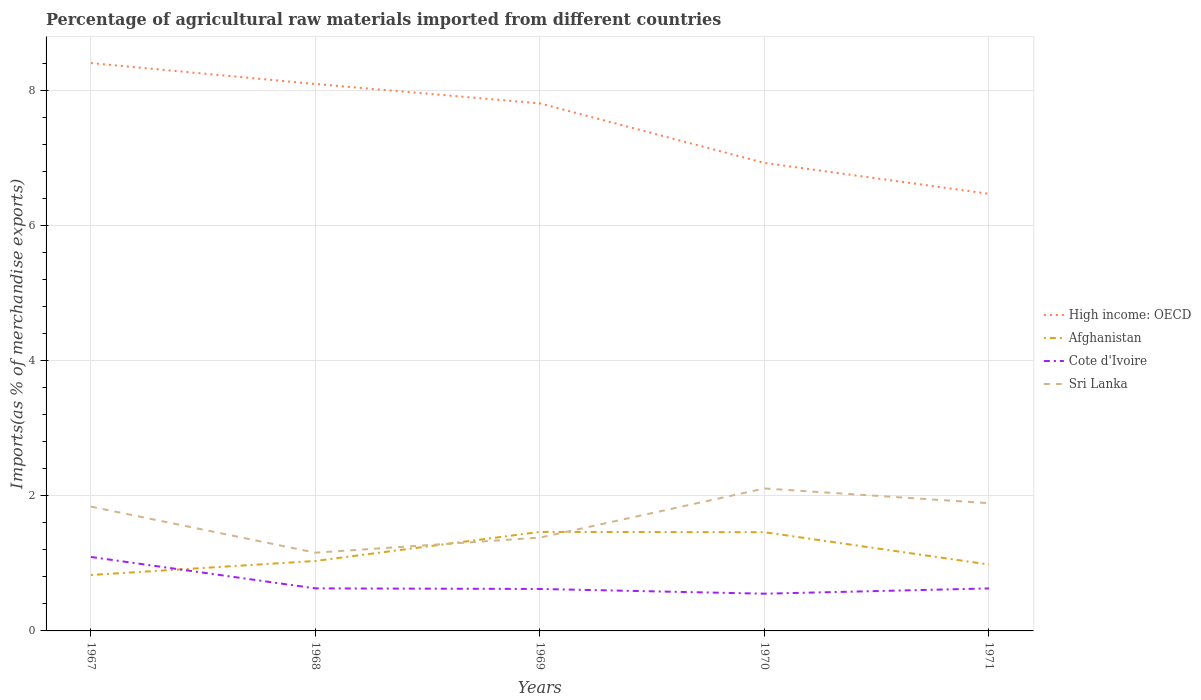How many different coloured lines are there?
Give a very brief answer. 4. Is the number of lines equal to the number of legend labels?
Give a very brief answer. Yes. Across all years, what is the maximum percentage of imports to different countries in Sri Lanka?
Your response must be concise. 1.16. What is the total percentage of imports to different countries in Sri Lanka in the graph?
Your response must be concise. -0.73. What is the difference between the highest and the second highest percentage of imports to different countries in Sri Lanka?
Offer a terse response. 0.95. How many lines are there?
Your answer should be compact. 4. What is the difference between two consecutive major ticks on the Y-axis?
Offer a terse response. 2. Are the values on the major ticks of Y-axis written in scientific E-notation?
Provide a succinct answer. No. Where does the legend appear in the graph?
Give a very brief answer. Center right. How many legend labels are there?
Offer a very short reply. 4. What is the title of the graph?
Offer a very short reply. Percentage of agricultural raw materials imported from different countries. Does "India" appear as one of the legend labels in the graph?
Offer a terse response. No. What is the label or title of the Y-axis?
Provide a succinct answer. Imports(as % of merchandise exports). What is the Imports(as % of merchandise exports) of High income: OECD in 1967?
Ensure brevity in your answer.  8.4. What is the Imports(as % of merchandise exports) of Afghanistan in 1967?
Provide a succinct answer. 0.83. What is the Imports(as % of merchandise exports) in Cote d'Ivoire in 1967?
Ensure brevity in your answer.  1.09. What is the Imports(as % of merchandise exports) in Sri Lanka in 1967?
Ensure brevity in your answer.  1.84. What is the Imports(as % of merchandise exports) of High income: OECD in 1968?
Provide a succinct answer. 8.09. What is the Imports(as % of merchandise exports) in Afghanistan in 1968?
Ensure brevity in your answer.  1.04. What is the Imports(as % of merchandise exports) of Cote d'Ivoire in 1968?
Give a very brief answer. 0.63. What is the Imports(as % of merchandise exports) in Sri Lanka in 1968?
Provide a short and direct response. 1.16. What is the Imports(as % of merchandise exports) of High income: OECD in 1969?
Provide a succinct answer. 7.8. What is the Imports(as % of merchandise exports) in Afghanistan in 1969?
Provide a succinct answer. 1.46. What is the Imports(as % of merchandise exports) of Cote d'Ivoire in 1969?
Make the answer very short. 0.62. What is the Imports(as % of merchandise exports) of Sri Lanka in 1969?
Give a very brief answer. 1.38. What is the Imports(as % of merchandise exports) in High income: OECD in 1970?
Your answer should be compact. 6.92. What is the Imports(as % of merchandise exports) in Afghanistan in 1970?
Give a very brief answer. 1.46. What is the Imports(as % of merchandise exports) of Cote d'Ivoire in 1970?
Make the answer very short. 0.55. What is the Imports(as % of merchandise exports) in Sri Lanka in 1970?
Make the answer very short. 2.11. What is the Imports(as % of merchandise exports) in High income: OECD in 1971?
Ensure brevity in your answer.  6.47. What is the Imports(as % of merchandise exports) of Afghanistan in 1971?
Your answer should be very brief. 0.98. What is the Imports(as % of merchandise exports) in Cote d'Ivoire in 1971?
Your response must be concise. 0.63. What is the Imports(as % of merchandise exports) in Sri Lanka in 1971?
Make the answer very short. 1.89. Across all years, what is the maximum Imports(as % of merchandise exports) of High income: OECD?
Ensure brevity in your answer.  8.4. Across all years, what is the maximum Imports(as % of merchandise exports) in Afghanistan?
Provide a succinct answer. 1.46. Across all years, what is the maximum Imports(as % of merchandise exports) of Cote d'Ivoire?
Offer a terse response. 1.09. Across all years, what is the maximum Imports(as % of merchandise exports) in Sri Lanka?
Give a very brief answer. 2.11. Across all years, what is the minimum Imports(as % of merchandise exports) of High income: OECD?
Offer a very short reply. 6.47. Across all years, what is the minimum Imports(as % of merchandise exports) in Afghanistan?
Provide a short and direct response. 0.83. Across all years, what is the minimum Imports(as % of merchandise exports) in Cote d'Ivoire?
Make the answer very short. 0.55. Across all years, what is the minimum Imports(as % of merchandise exports) in Sri Lanka?
Ensure brevity in your answer.  1.16. What is the total Imports(as % of merchandise exports) of High income: OECD in the graph?
Make the answer very short. 37.69. What is the total Imports(as % of merchandise exports) in Afghanistan in the graph?
Offer a terse response. 5.77. What is the total Imports(as % of merchandise exports) of Cote d'Ivoire in the graph?
Provide a short and direct response. 3.52. What is the total Imports(as % of merchandise exports) of Sri Lanka in the graph?
Give a very brief answer. 8.37. What is the difference between the Imports(as % of merchandise exports) in High income: OECD in 1967 and that in 1968?
Provide a succinct answer. 0.31. What is the difference between the Imports(as % of merchandise exports) of Afghanistan in 1967 and that in 1968?
Your answer should be very brief. -0.21. What is the difference between the Imports(as % of merchandise exports) in Cote d'Ivoire in 1967 and that in 1968?
Offer a terse response. 0.46. What is the difference between the Imports(as % of merchandise exports) in Sri Lanka in 1967 and that in 1968?
Ensure brevity in your answer.  0.68. What is the difference between the Imports(as % of merchandise exports) in High income: OECD in 1967 and that in 1969?
Offer a very short reply. 0.6. What is the difference between the Imports(as % of merchandise exports) of Afghanistan in 1967 and that in 1969?
Keep it short and to the point. -0.64. What is the difference between the Imports(as % of merchandise exports) in Cote d'Ivoire in 1967 and that in 1969?
Offer a very short reply. 0.47. What is the difference between the Imports(as % of merchandise exports) in Sri Lanka in 1967 and that in 1969?
Offer a terse response. 0.46. What is the difference between the Imports(as % of merchandise exports) of High income: OECD in 1967 and that in 1970?
Your response must be concise. 1.48. What is the difference between the Imports(as % of merchandise exports) of Afghanistan in 1967 and that in 1970?
Your answer should be very brief. -0.63. What is the difference between the Imports(as % of merchandise exports) of Cote d'Ivoire in 1967 and that in 1970?
Ensure brevity in your answer.  0.54. What is the difference between the Imports(as % of merchandise exports) of Sri Lanka in 1967 and that in 1970?
Provide a succinct answer. -0.27. What is the difference between the Imports(as % of merchandise exports) of High income: OECD in 1967 and that in 1971?
Keep it short and to the point. 1.93. What is the difference between the Imports(as % of merchandise exports) of Afghanistan in 1967 and that in 1971?
Provide a succinct answer. -0.15. What is the difference between the Imports(as % of merchandise exports) in Cote d'Ivoire in 1967 and that in 1971?
Make the answer very short. 0.47. What is the difference between the Imports(as % of merchandise exports) of Sri Lanka in 1967 and that in 1971?
Provide a short and direct response. -0.05. What is the difference between the Imports(as % of merchandise exports) in High income: OECD in 1968 and that in 1969?
Give a very brief answer. 0.29. What is the difference between the Imports(as % of merchandise exports) in Afghanistan in 1968 and that in 1969?
Ensure brevity in your answer.  -0.43. What is the difference between the Imports(as % of merchandise exports) in Cote d'Ivoire in 1968 and that in 1969?
Make the answer very short. 0.01. What is the difference between the Imports(as % of merchandise exports) in Sri Lanka in 1968 and that in 1969?
Ensure brevity in your answer.  -0.22. What is the difference between the Imports(as % of merchandise exports) in High income: OECD in 1968 and that in 1970?
Your answer should be very brief. 1.17. What is the difference between the Imports(as % of merchandise exports) of Afghanistan in 1968 and that in 1970?
Give a very brief answer. -0.43. What is the difference between the Imports(as % of merchandise exports) of Cote d'Ivoire in 1968 and that in 1970?
Provide a succinct answer. 0.08. What is the difference between the Imports(as % of merchandise exports) in Sri Lanka in 1968 and that in 1970?
Provide a short and direct response. -0.95. What is the difference between the Imports(as % of merchandise exports) in High income: OECD in 1968 and that in 1971?
Your answer should be compact. 1.62. What is the difference between the Imports(as % of merchandise exports) of Afghanistan in 1968 and that in 1971?
Offer a terse response. 0.05. What is the difference between the Imports(as % of merchandise exports) in Cote d'Ivoire in 1968 and that in 1971?
Keep it short and to the point. 0. What is the difference between the Imports(as % of merchandise exports) in Sri Lanka in 1968 and that in 1971?
Provide a short and direct response. -0.73. What is the difference between the Imports(as % of merchandise exports) of High income: OECD in 1969 and that in 1970?
Provide a short and direct response. 0.88. What is the difference between the Imports(as % of merchandise exports) in Afghanistan in 1969 and that in 1970?
Provide a short and direct response. 0. What is the difference between the Imports(as % of merchandise exports) in Cote d'Ivoire in 1969 and that in 1970?
Your response must be concise. 0.07. What is the difference between the Imports(as % of merchandise exports) of Sri Lanka in 1969 and that in 1970?
Your response must be concise. -0.73. What is the difference between the Imports(as % of merchandise exports) of High income: OECD in 1969 and that in 1971?
Your answer should be very brief. 1.34. What is the difference between the Imports(as % of merchandise exports) in Afghanistan in 1969 and that in 1971?
Provide a short and direct response. 0.48. What is the difference between the Imports(as % of merchandise exports) of Cote d'Ivoire in 1969 and that in 1971?
Provide a short and direct response. -0.01. What is the difference between the Imports(as % of merchandise exports) in Sri Lanka in 1969 and that in 1971?
Your response must be concise. -0.51. What is the difference between the Imports(as % of merchandise exports) of High income: OECD in 1970 and that in 1971?
Offer a terse response. 0.46. What is the difference between the Imports(as % of merchandise exports) in Afghanistan in 1970 and that in 1971?
Offer a very short reply. 0.48. What is the difference between the Imports(as % of merchandise exports) of Cote d'Ivoire in 1970 and that in 1971?
Keep it short and to the point. -0.08. What is the difference between the Imports(as % of merchandise exports) of Sri Lanka in 1970 and that in 1971?
Your response must be concise. 0.22. What is the difference between the Imports(as % of merchandise exports) in High income: OECD in 1967 and the Imports(as % of merchandise exports) in Afghanistan in 1968?
Ensure brevity in your answer.  7.37. What is the difference between the Imports(as % of merchandise exports) of High income: OECD in 1967 and the Imports(as % of merchandise exports) of Cote d'Ivoire in 1968?
Give a very brief answer. 7.77. What is the difference between the Imports(as % of merchandise exports) of High income: OECD in 1967 and the Imports(as % of merchandise exports) of Sri Lanka in 1968?
Offer a very short reply. 7.24. What is the difference between the Imports(as % of merchandise exports) in Afghanistan in 1967 and the Imports(as % of merchandise exports) in Cote d'Ivoire in 1968?
Offer a terse response. 0.2. What is the difference between the Imports(as % of merchandise exports) in Afghanistan in 1967 and the Imports(as % of merchandise exports) in Sri Lanka in 1968?
Your answer should be compact. -0.33. What is the difference between the Imports(as % of merchandise exports) in Cote d'Ivoire in 1967 and the Imports(as % of merchandise exports) in Sri Lanka in 1968?
Your response must be concise. -0.06. What is the difference between the Imports(as % of merchandise exports) of High income: OECD in 1967 and the Imports(as % of merchandise exports) of Afghanistan in 1969?
Give a very brief answer. 6.94. What is the difference between the Imports(as % of merchandise exports) of High income: OECD in 1967 and the Imports(as % of merchandise exports) of Cote d'Ivoire in 1969?
Keep it short and to the point. 7.78. What is the difference between the Imports(as % of merchandise exports) of High income: OECD in 1967 and the Imports(as % of merchandise exports) of Sri Lanka in 1969?
Make the answer very short. 7.02. What is the difference between the Imports(as % of merchandise exports) in Afghanistan in 1967 and the Imports(as % of merchandise exports) in Cote d'Ivoire in 1969?
Give a very brief answer. 0.21. What is the difference between the Imports(as % of merchandise exports) of Afghanistan in 1967 and the Imports(as % of merchandise exports) of Sri Lanka in 1969?
Offer a very short reply. -0.55. What is the difference between the Imports(as % of merchandise exports) of Cote d'Ivoire in 1967 and the Imports(as % of merchandise exports) of Sri Lanka in 1969?
Your response must be concise. -0.29. What is the difference between the Imports(as % of merchandise exports) of High income: OECD in 1967 and the Imports(as % of merchandise exports) of Afghanistan in 1970?
Keep it short and to the point. 6.94. What is the difference between the Imports(as % of merchandise exports) of High income: OECD in 1967 and the Imports(as % of merchandise exports) of Cote d'Ivoire in 1970?
Ensure brevity in your answer.  7.85. What is the difference between the Imports(as % of merchandise exports) in High income: OECD in 1967 and the Imports(as % of merchandise exports) in Sri Lanka in 1970?
Keep it short and to the point. 6.29. What is the difference between the Imports(as % of merchandise exports) of Afghanistan in 1967 and the Imports(as % of merchandise exports) of Cote d'Ivoire in 1970?
Offer a terse response. 0.28. What is the difference between the Imports(as % of merchandise exports) of Afghanistan in 1967 and the Imports(as % of merchandise exports) of Sri Lanka in 1970?
Provide a succinct answer. -1.28. What is the difference between the Imports(as % of merchandise exports) in Cote d'Ivoire in 1967 and the Imports(as % of merchandise exports) in Sri Lanka in 1970?
Provide a short and direct response. -1.01. What is the difference between the Imports(as % of merchandise exports) of High income: OECD in 1967 and the Imports(as % of merchandise exports) of Afghanistan in 1971?
Keep it short and to the point. 7.42. What is the difference between the Imports(as % of merchandise exports) of High income: OECD in 1967 and the Imports(as % of merchandise exports) of Cote d'Ivoire in 1971?
Offer a very short reply. 7.77. What is the difference between the Imports(as % of merchandise exports) of High income: OECD in 1967 and the Imports(as % of merchandise exports) of Sri Lanka in 1971?
Provide a succinct answer. 6.51. What is the difference between the Imports(as % of merchandise exports) of Afghanistan in 1967 and the Imports(as % of merchandise exports) of Cote d'Ivoire in 1971?
Your answer should be compact. 0.2. What is the difference between the Imports(as % of merchandise exports) in Afghanistan in 1967 and the Imports(as % of merchandise exports) in Sri Lanka in 1971?
Provide a short and direct response. -1.06. What is the difference between the Imports(as % of merchandise exports) in Cote d'Ivoire in 1967 and the Imports(as % of merchandise exports) in Sri Lanka in 1971?
Give a very brief answer. -0.8. What is the difference between the Imports(as % of merchandise exports) of High income: OECD in 1968 and the Imports(as % of merchandise exports) of Afghanistan in 1969?
Your response must be concise. 6.63. What is the difference between the Imports(as % of merchandise exports) in High income: OECD in 1968 and the Imports(as % of merchandise exports) in Cote d'Ivoire in 1969?
Offer a terse response. 7.47. What is the difference between the Imports(as % of merchandise exports) of High income: OECD in 1968 and the Imports(as % of merchandise exports) of Sri Lanka in 1969?
Your answer should be compact. 6.71. What is the difference between the Imports(as % of merchandise exports) in Afghanistan in 1968 and the Imports(as % of merchandise exports) in Cote d'Ivoire in 1969?
Your answer should be compact. 0.41. What is the difference between the Imports(as % of merchandise exports) of Afghanistan in 1968 and the Imports(as % of merchandise exports) of Sri Lanka in 1969?
Your answer should be compact. -0.35. What is the difference between the Imports(as % of merchandise exports) in Cote d'Ivoire in 1968 and the Imports(as % of merchandise exports) in Sri Lanka in 1969?
Provide a succinct answer. -0.75. What is the difference between the Imports(as % of merchandise exports) in High income: OECD in 1968 and the Imports(as % of merchandise exports) in Afghanistan in 1970?
Provide a succinct answer. 6.63. What is the difference between the Imports(as % of merchandise exports) in High income: OECD in 1968 and the Imports(as % of merchandise exports) in Cote d'Ivoire in 1970?
Give a very brief answer. 7.54. What is the difference between the Imports(as % of merchandise exports) of High income: OECD in 1968 and the Imports(as % of merchandise exports) of Sri Lanka in 1970?
Your answer should be very brief. 5.98. What is the difference between the Imports(as % of merchandise exports) in Afghanistan in 1968 and the Imports(as % of merchandise exports) in Cote d'Ivoire in 1970?
Offer a very short reply. 0.48. What is the difference between the Imports(as % of merchandise exports) of Afghanistan in 1968 and the Imports(as % of merchandise exports) of Sri Lanka in 1970?
Provide a short and direct response. -1.07. What is the difference between the Imports(as % of merchandise exports) in Cote d'Ivoire in 1968 and the Imports(as % of merchandise exports) in Sri Lanka in 1970?
Your answer should be very brief. -1.48. What is the difference between the Imports(as % of merchandise exports) in High income: OECD in 1968 and the Imports(as % of merchandise exports) in Afghanistan in 1971?
Make the answer very short. 7.11. What is the difference between the Imports(as % of merchandise exports) of High income: OECD in 1968 and the Imports(as % of merchandise exports) of Cote d'Ivoire in 1971?
Offer a terse response. 7.46. What is the difference between the Imports(as % of merchandise exports) in High income: OECD in 1968 and the Imports(as % of merchandise exports) in Sri Lanka in 1971?
Keep it short and to the point. 6.2. What is the difference between the Imports(as % of merchandise exports) in Afghanistan in 1968 and the Imports(as % of merchandise exports) in Cote d'Ivoire in 1971?
Your answer should be very brief. 0.41. What is the difference between the Imports(as % of merchandise exports) in Afghanistan in 1968 and the Imports(as % of merchandise exports) in Sri Lanka in 1971?
Your answer should be compact. -0.85. What is the difference between the Imports(as % of merchandise exports) in Cote d'Ivoire in 1968 and the Imports(as % of merchandise exports) in Sri Lanka in 1971?
Keep it short and to the point. -1.26. What is the difference between the Imports(as % of merchandise exports) in High income: OECD in 1969 and the Imports(as % of merchandise exports) in Afghanistan in 1970?
Your answer should be very brief. 6.34. What is the difference between the Imports(as % of merchandise exports) in High income: OECD in 1969 and the Imports(as % of merchandise exports) in Cote d'Ivoire in 1970?
Provide a succinct answer. 7.25. What is the difference between the Imports(as % of merchandise exports) in High income: OECD in 1969 and the Imports(as % of merchandise exports) in Sri Lanka in 1970?
Offer a very short reply. 5.7. What is the difference between the Imports(as % of merchandise exports) of Afghanistan in 1969 and the Imports(as % of merchandise exports) of Cote d'Ivoire in 1970?
Your answer should be compact. 0.91. What is the difference between the Imports(as % of merchandise exports) of Afghanistan in 1969 and the Imports(as % of merchandise exports) of Sri Lanka in 1970?
Your answer should be compact. -0.64. What is the difference between the Imports(as % of merchandise exports) of Cote d'Ivoire in 1969 and the Imports(as % of merchandise exports) of Sri Lanka in 1970?
Provide a short and direct response. -1.49. What is the difference between the Imports(as % of merchandise exports) in High income: OECD in 1969 and the Imports(as % of merchandise exports) in Afghanistan in 1971?
Provide a short and direct response. 6.82. What is the difference between the Imports(as % of merchandise exports) of High income: OECD in 1969 and the Imports(as % of merchandise exports) of Cote d'Ivoire in 1971?
Provide a short and direct response. 7.18. What is the difference between the Imports(as % of merchandise exports) of High income: OECD in 1969 and the Imports(as % of merchandise exports) of Sri Lanka in 1971?
Your answer should be compact. 5.91. What is the difference between the Imports(as % of merchandise exports) of Afghanistan in 1969 and the Imports(as % of merchandise exports) of Cote d'Ivoire in 1971?
Your answer should be very brief. 0.84. What is the difference between the Imports(as % of merchandise exports) of Afghanistan in 1969 and the Imports(as % of merchandise exports) of Sri Lanka in 1971?
Offer a very short reply. -0.43. What is the difference between the Imports(as % of merchandise exports) in Cote d'Ivoire in 1969 and the Imports(as % of merchandise exports) in Sri Lanka in 1971?
Keep it short and to the point. -1.27. What is the difference between the Imports(as % of merchandise exports) in High income: OECD in 1970 and the Imports(as % of merchandise exports) in Afghanistan in 1971?
Offer a terse response. 5.94. What is the difference between the Imports(as % of merchandise exports) of High income: OECD in 1970 and the Imports(as % of merchandise exports) of Cote d'Ivoire in 1971?
Provide a succinct answer. 6.29. What is the difference between the Imports(as % of merchandise exports) of High income: OECD in 1970 and the Imports(as % of merchandise exports) of Sri Lanka in 1971?
Your answer should be compact. 5.03. What is the difference between the Imports(as % of merchandise exports) of Afghanistan in 1970 and the Imports(as % of merchandise exports) of Cote d'Ivoire in 1971?
Give a very brief answer. 0.83. What is the difference between the Imports(as % of merchandise exports) of Afghanistan in 1970 and the Imports(as % of merchandise exports) of Sri Lanka in 1971?
Offer a very short reply. -0.43. What is the difference between the Imports(as % of merchandise exports) of Cote d'Ivoire in 1970 and the Imports(as % of merchandise exports) of Sri Lanka in 1971?
Your answer should be compact. -1.34. What is the average Imports(as % of merchandise exports) of High income: OECD per year?
Keep it short and to the point. 7.54. What is the average Imports(as % of merchandise exports) of Afghanistan per year?
Keep it short and to the point. 1.15. What is the average Imports(as % of merchandise exports) in Cote d'Ivoire per year?
Your answer should be compact. 0.7. What is the average Imports(as % of merchandise exports) of Sri Lanka per year?
Offer a very short reply. 1.67. In the year 1967, what is the difference between the Imports(as % of merchandise exports) in High income: OECD and Imports(as % of merchandise exports) in Afghanistan?
Provide a succinct answer. 7.57. In the year 1967, what is the difference between the Imports(as % of merchandise exports) in High income: OECD and Imports(as % of merchandise exports) in Cote d'Ivoire?
Ensure brevity in your answer.  7.31. In the year 1967, what is the difference between the Imports(as % of merchandise exports) in High income: OECD and Imports(as % of merchandise exports) in Sri Lanka?
Make the answer very short. 6.56. In the year 1967, what is the difference between the Imports(as % of merchandise exports) of Afghanistan and Imports(as % of merchandise exports) of Cote d'Ivoire?
Offer a terse response. -0.27. In the year 1967, what is the difference between the Imports(as % of merchandise exports) in Afghanistan and Imports(as % of merchandise exports) in Sri Lanka?
Provide a succinct answer. -1.01. In the year 1967, what is the difference between the Imports(as % of merchandise exports) in Cote d'Ivoire and Imports(as % of merchandise exports) in Sri Lanka?
Provide a short and direct response. -0.74. In the year 1968, what is the difference between the Imports(as % of merchandise exports) in High income: OECD and Imports(as % of merchandise exports) in Afghanistan?
Make the answer very short. 7.06. In the year 1968, what is the difference between the Imports(as % of merchandise exports) in High income: OECD and Imports(as % of merchandise exports) in Cote d'Ivoire?
Make the answer very short. 7.46. In the year 1968, what is the difference between the Imports(as % of merchandise exports) of High income: OECD and Imports(as % of merchandise exports) of Sri Lanka?
Provide a short and direct response. 6.93. In the year 1968, what is the difference between the Imports(as % of merchandise exports) of Afghanistan and Imports(as % of merchandise exports) of Cote d'Ivoire?
Your answer should be compact. 0.41. In the year 1968, what is the difference between the Imports(as % of merchandise exports) in Afghanistan and Imports(as % of merchandise exports) in Sri Lanka?
Keep it short and to the point. -0.12. In the year 1968, what is the difference between the Imports(as % of merchandise exports) in Cote d'Ivoire and Imports(as % of merchandise exports) in Sri Lanka?
Keep it short and to the point. -0.53. In the year 1969, what is the difference between the Imports(as % of merchandise exports) of High income: OECD and Imports(as % of merchandise exports) of Afghanistan?
Keep it short and to the point. 6.34. In the year 1969, what is the difference between the Imports(as % of merchandise exports) of High income: OECD and Imports(as % of merchandise exports) of Cote d'Ivoire?
Give a very brief answer. 7.18. In the year 1969, what is the difference between the Imports(as % of merchandise exports) in High income: OECD and Imports(as % of merchandise exports) in Sri Lanka?
Your answer should be compact. 6.42. In the year 1969, what is the difference between the Imports(as % of merchandise exports) of Afghanistan and Imports(as % of merchandise exports) of Cote d'Ivoire?
Provide a succinct answer. 0.84. In the year 1969, what is the difference between the Imports(as % of merchandise exports) of Afghanistan and Imports(as % of merchandise exports) of Sri Lanka?
Give a very brief answer. 0.08. In the year 1969, what is the difference between the Imports(as % of merchandise exports) in Cote d'Ivoire and Imports(as % of merchandise exports) in Sri Lanka?
Keep it short and to the point. -0.76. In the year 1970, what is the difference between the Imports(as % of merchandise exports) in High income: OECD and Imports(as % of merchandise exports) in Afghanistan?
Ensure brevity in your answer.  5.46. In the year 1970, what is the difference between the Imports(as % of merchandise exports) of High income: OECD and Imports(as % of merchandise exports) of Cote d'Ivoire?
Keep it short and to the point. 6.37. In the year 1970, what is the difference between the Imports(as % of merchandise exports) in High income: OECD and Imports(as % of merchandise exports) in Sri Lanka?
Make the answer very short. 4.82. In the year 1970, what is the difference between the Imports(as % of merchandise exports) in Afghanistan and Imports(as % of merchandise exports) in Cote d'Ivoire?
Provide a succinct answer. 0.91. In the year 1970, what is the difference between the Imports(as % of merchandise exports) in Afghanistan and Imports(as % of merchandise exports) in Sri Lanka?
Keep it short and to the point. -0.65. In the year 1970, what is the difference between the Imports(as % of merchandise exports) in Cote d'Ivoire and Imports(as % of merchandise exports) in Sri Lanka?
Give a very brief answer. -1.56. In the year 1971, what is the difference between the Imports(as % of merchandise exports) in High income: OECD and Imports(as % of merchandise exports) in Afghanistan?
Ensure brevity in your answer.  5.48. In the year 1971, what is the difference between the Imports(as % of merchandise exports) in High income: OECD and Imports(as % of merchandise exports) in Cote d'Ivoire?
Provide a succinct answer. 5.84. In the year 1971, what is the difference between the Imports(as % of merchandise exports) in High income: OECD and Imports(as % of merchandise exports) in Sri Lanka?
Offer a very short reply. 4.58. In the year 1971, what is the difference between the Imports(as % of merchandise exports) in Afghanistan and Imports(as % of merchandise exports) in Cote d'Ivoire?
Provide a succinct answer. 0.35. In the year 1971, what is the difference between the Imports(as % of merchandise exports) of Afghanistan and Imports(as % of merchandise exports) of Sri Lanka?
Ensure brevity in your answer.  -0.91. In the year 1971, what is the difference between the Imports(as % of merchandise exports) in Cote d'Ivoire and Imports(as % of merchandise exports) in Sri Lanka?
Your response must be concise. -1.26. What is the ratio of the Imports(as % of merchandise exports) of High income: OECD in 1967 to that in 1968?
Ensure brevity in your answer.  1.04. What is the ratio of the Imports(as % of merchandise exports) of Afghanistan in 1967 to that in 1968?
Keep it short and to the point. 0.8. What is the ratio of the Imports(as % of merchandise exports) of Cote d'Ivoire in 1967 to that in 1968?
Your answer should be compact. 1.74. What is the ratio of the Imports(as % of merchandise exports) of Sri Lanka in 1967 to that in 1968?
Make the answer very short. 1.59. What is the ratio of the Imports(as % of merchandise exports) in High income: OECD in 1967 to that in 1969?
Your answer should be very brief. 1.08. What is the ratio of the Imports(as % of merchandise exports) in Afghanistan in 1967 to that in 1969?
Make the answer very short. 0.56. What is the ratio of the Imports(as % of merchandise exports) in Cote d'Ivoire in 1967 to that in 1969?
Your response must be concise. 1.76. What is the ratio of the Imports(as % of merchandise exports) of Sri Lanka in 1967 to that in 1969?
Your answer should be very brief. 1.33. What is the ratio of the Imports(as % of merchandise exports) of High income: OECD in 1967 to that in 1970?
Your answer should be compact. 1.21. What is the ratio of the Imports(as % of merchandise exports) in Afghanistan in 1967 to that in 1970?
Your answer should be compact. 0.57. What is the ratio of the Imports(as % of merchandise exports) in Cote d'Ivoire in 1967 to that in 1970?
Offer a terse response. 1.99. What is the ratio of the Imports(as % of merchandise exports) in Sri Lanka in 1967 to that in 1970?
Provide a short and direct response. 0.87. What is the ratio of the Imports(as % of merchandise exports) in High income: OECD in 1967 to that in 1971?
Provide a short and direct response. 1.3. What is the ratio of the Imports(as % of merchandise exports) of Afghanistan in 1967 to that in 1971?
Make the answer very short. 0.84. What is the ratio of the Imports(as % of merchandise exports) in Cote d'Ivoire in 1967 to that in 1971?
Your answer should be very brief. 1.74. What is the ratio of the Imports(as % of merchandise exports) in Sri Lanka in 1967 to that in 1971?
Provide a short and direct response. 0.97. What is the ratio of the Imports(as % of merchandise exports) in High income: OECD in 1968 to that in 1969?
Provide a succinct answer. 1.04. What is the ratio of the Imports(as % of merchandise exports) in Afghanistan in 1968 to that in 1969?
Provide a short and direct response. 0.71. What is the ratio of the Imports(as % of merchandise exports) in Cote d'Ivoire in 1968 to that in 1969?
Offer a terse response. 1.01. What is the ratio of the Imports(as % of merchandise exports) of Sri Lanka in 1968 to that in 1969?
Provide a short and direct response. 0.84. What is the ratio of the Imports(as % of merchandise exports) in High income: OECD in 1968 to that in 1970?
Offer a very short reply. 1.17. What is the ratio of the Imports(as % of merchandise exports) in Afghanistan in 1968 to that in 1970?
Offer a very short reply. 0.71. What is the ratio of the Imports(as % of merchandise exports) of Cote d'Ivoire in 1968 to that in 1970?
Ensure brevity in your answer.  1.14. What is the ratio of the Imports(as % of merchandise exports) of Sri Lanka in 1968 to that in 1970?
Provide a succinct answer. 0.55. What is the ratio of the Imports(as % of merchandise exports) of High income: OECD in 1968 to that in 1971?
Your answer should be very brief. 1.25. What is the ratio of the Imports(as % of merchandise exports) of Afghanistan in 1968 to that in 1971?
Offer a very short reply. 1.05. What is the ratio of the Imports(as % of merchandise exports) of Sri Lanka in 1968 to that in 1971?
Provide a succinct answer. 0.61. What is the ratio of the Imports(as % of merchandise exports) in High income: OECD in 1969 to that in 1970?
Your answer should be very brief. 1.13. What is the ratio of the Imports(as % of merchandise exports) in Afghanistan in 1969 to that in 1970?
Ensure brevity in your answer.  1. What is the ratio of the Imports(as % of merchandise exports) in Cote d'Ivoire in 1969 to that in 1970?
Your answer should be compact. 1.13. What is the ratio of the Imports(as % of merchandise exports) in Sri Lanka in 1969 to that in 1970?
Ensure brevity in your answer.  0.66. What is the ratio of the Imports(as % of merchandise exports) of High income: OECD in 1969 to that in 1971?
Provide a succinct answer. 1.21. What is the ratio of the Imports(as % of merchandise exports) in Afghanistan in 1969 to that in 1971?
Make the answer very short. 1.49. What is the ratio of the Imports(as % of merchandise exports) in Cote d'Ivoire in 1969 to that in 1971?
Offer a terse response. 0.99. What is the ratio of the Imports(as % of merchandise exports) in Sri Lanka in 1969 to that in 1971?
Keep it short and to the point. 0.73. What is the ratio of the Imports(as % of merchandise exports) in High income: OECD in 1970 to that in 1971?
Ensure brevity in your answer.  1.07. What is the ratio of the Imports(as % of merchandise exports) of Afghanistan in 1970 to that in 1971?
Ensure brevity in your answer.  1.49. What is the ratio of the Imports(as % of merchandise exports) of Cote d'Ivoire in 1970 to that in 1971?
Keep it short and to the point. 0.88. What is the ratio of the Imports(as % of merchandise exports) in Sri Lanka in 1970 to that in 1971?
Provide a short and direct response. 1.12. What is the difference between the highest and the second highest Imports(as % of merchandise exports) of High income: OECD?
Ensure brevity in your answer.  0.31. What is the difference between the highest and the second highest Imports(as % of merchandise exports) in Afghanistan?
Your response must be concise. 0. What is the difference between the highest and the second highest Imports(as % of merchandise exports) of Cote d'Ivoire?
Offer a very short reply. 0.46. What is the difference between the highest and the second highest Imports(as % of merchandise exports) of Sri Lanka?
Ensure brevity in your answer.  0.22. What is the difference between the highest and the lowest Imports(as % of merchandise exports) of High income: OECD?
Provide a succinct answer. 1.93. What is the difference between the highest and the lowest Imports(as % of merchandise exports) in Afghanistan?
Give a very brief answer. 0.64. What is the difference between the highest and the lowest Imports(as % of merchandise exports) in Cote d'Ivoire?
Offer a very short reply. 0.54. What is the difference between the highest and the lowest Imports(as % of merchandise exports) of Sri Lanka?
Your answer should be compact. 0.95. 